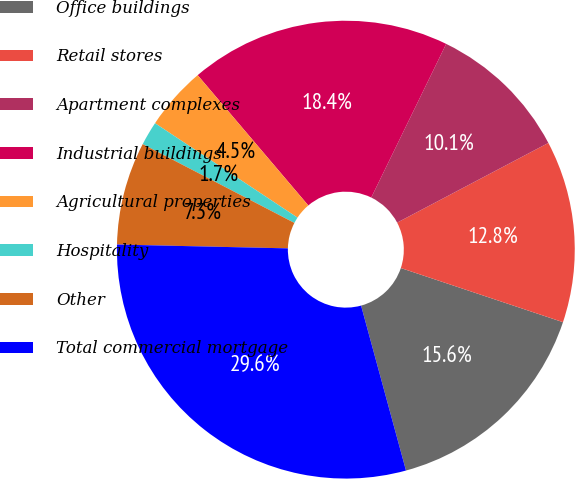<chart> <loc_0><loc_0><loc_500><loc_500><pie_chart><fcel>Office buildings<fcel>Retail stores<fcel>Apartment complexes<fcel>Industrial buildings<fcel>Agricultural properties<fcel>Hospitality<fcel>Other<fcel>Total commercial mortgage<nl><fcel>15.64%<fcel>12.85%<fcel>10.06%<fcel>18.43%<fcel>4.48%<fcel>1.69%<fcel>7.27%<fcel>29.59%<nl></chart> 